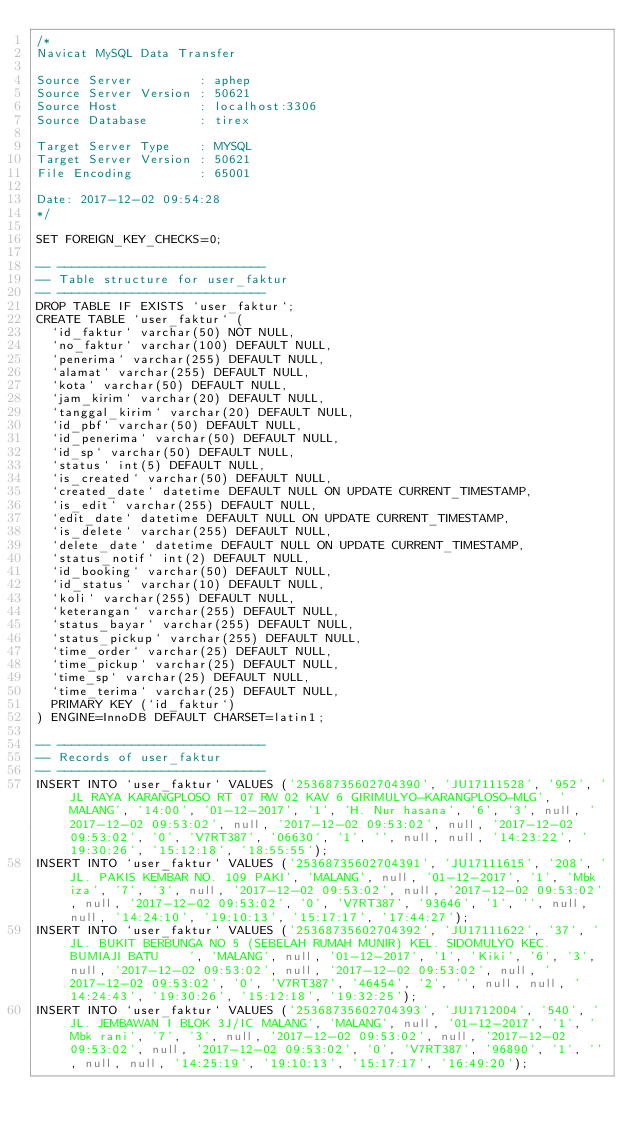<code> <loc_0><loc_0><loc_500><loc_500><_SQL_>/*
Navicat MySQL Data Transfer

Source Server         : aphep
Source Server Version : 50621
Source Host           : localhost:3306
Source Database       : tirex

Target Server Type    : MYSQL
Target Server Version : 50621
File Encoding         : 65001

Date: 2017-12-02 09:54:28
*/

SET FOREIGN_KEY_CHECKS=0;

-- ----------------------------
-- Table structure for user_faktur
-- ----------------------------
DROP TABLE IF EXISTS `user_faktur`;
CREATE TABLE `user_faktur` (
  `id_faktur` varchar(50) NOT NULL,
  `no_faktur` varchar(100) DEFAULT NULL,
  `penerima` varchar(255) DEFAULT NULL,
  `alamat` varchar(255) DEFAULT NULL,
  `kota` varchar(50) DEFAULT NULL,
  `jam_kirim` varchar(20) DEFAULT NULL,
  `tanggal_kirim` varchar(20) DEFAULT NULL,
  `id_pbf` varchar(50) DEFAULT NULL,
  `id_penerima` varchar(50) DEFAULT NULL,
  `id_sp` varchar(50) DEFAULT NULL,
  `status` int(5) DEFAULT NULL,
  `is_created` varchar(50) DEFAULT NULL,
  `created_date` datetime DEFAULT NULL ON UPDATE CURRENT_TIMESTAMP,
  `is_edit` varchar(255) DEFAULT NULL,
  `edit_date` datetime DEFAULT NULL ON UPDATE CURRENT_TIMESTAMP,
  `is_delete` varchar(255) DEFAULT NULL,
  `delete_date` datetime DEFAULT NULL ON UPDATE CURRENT_TIMESTAMP,
  `status_notif` int(2) DEFAULT NULL,
  `id_booking` varchar(50) DEFAULT NULL,
  `id_status` varchar(10) DEFAULT NULL,
  `koli` varchar(255) DEFAULT NULL,
  `keterangan` varchar(255) DEFAULT NULL,
  `status_bayar` varchar(255) DEFAULT NULL,
  `status_pickup` varchar(255) DEFAULT NULL,
  `time_order` varchar(25) DEFAULT NULL,
  `time_pickup` varchar(25) DEFAULT NULL,
  `time_sp` varchar(25) DEFAULT NULL,
  `time_terima` varchar(25) DEFAULT NULL,
  PRIMARY KEY (`id_faktur`)
) ENGINE=InnoDB DEFAULT CHARSET=latin1;

-- ----------------------------
-- Records of user_faktur
-- ----------------------------
INSERT INTO `user_faktur` VALUES ('25368735602704390', 'JU17111528', '952', 'JL RAYA KARANGPLOSO RT 07 RW 02 KAV 6 GIRIMULYO-KARANGPLOSO-MLG', 'MALANG', '14:00', '01-12-2017', '1', 'H. Nur hasana', '6', '3', null, '2017-12-02 09:53:02', null, '2017-12-02 09:53:02', null, '2017-12-02 09:53:02', '0', 'V7RT387', '06630', '1', '', null, null, '14:23:22', '19:30:26', '15:12:18', '18:55:55');
INSERT INTO `user_faktur` VALUES ('25368735602704391', 'JU17111615', '208', 'JL. PAKIS KEMBAR NO. 109 PAKI', 'MALANG', null, '01-12-2017', '1', 'Mbk iza', '7', '3', null, '2017-12-02 09:53:02', null, '2017-12-02 09:53:02', null, '2017-12-02 09:53:02', '0', 'V7RT387', '93646', '1', '', null, null, '14:24:10', '19:10:13', '15:17:17', '17:44:27');
INSERT INTO `user_faktur` VALUES ('25368735602704392', 'JU17111622', '37', 'JL. BUKIT BERBUNGA NO 5 (SEBELAH RUMAH MUNIR) KEL. SIDOMULYO KEC. BUMIAJI BATU    ', 'MALANG', null, '01-12-2017', '1', 'Kiki', '6', '3', null, '2017-12-02 09:53:02', null, '2017-12-02 09:53:02', null, '2017-12-02 09:53:02', '0', 'V7RT387', '46454', '2', '', null, null, '14:24:43', '19:30:26', '15:12:18', '19:32:25');
INSERT INTO `user_faktur` VALUES ('25368735602704393', 'JU1712004', '540', 'JL. JEMBAWAN I BLOK 3J/IC MALANG', 'MALANG', null, '01-12-2017', '1', 'Mbk rani', '7', '3', null, '2017-12-02 09:53:02', null, '2017-12-02 09:53:02', null, '2017-12-02 09:53:02', '0', 'V7RT387', '96890', '1', '', null, null, '14:25:19', '19:10:13', '15:17:17', '16:49:20');</code> 